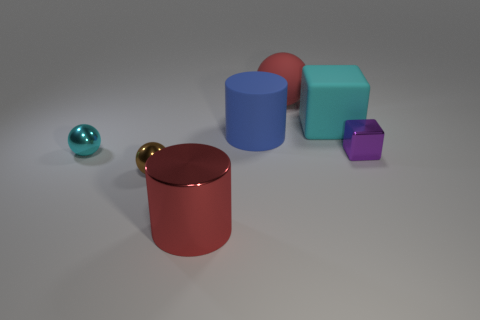Can you describe the arrangement of the objects with respect to each other? Certainly! In the image, we have a collection of different geometric shapes and colors. If you picture a line running from front to back, a small teal sphere is closest to the forefront on the left, followed by a small gold sphere. Near the center, there is a large red shiny cylinder. To the right of the cylinder, three cubes are arranged in a staggered line from front to back: a medium-sized blue cube closest to the cylinder, a large orange cube in the middle, and a small purple cube towards the back. 